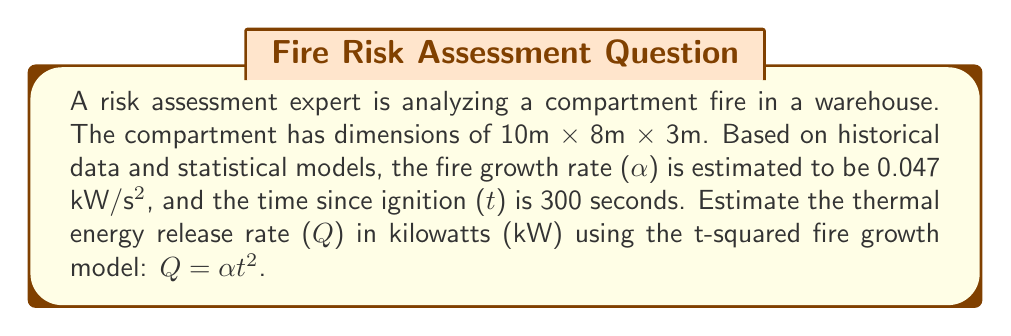Could you help me with this problem? To estimate the thermal energy release rate (Q) in a compartment fire using the t-squared fire growth model, we follow these steps:

1. Identify the given parameters:
   - Fire growth rate (α) = 0.047 kW/s²
   - Time since ignition (t) = 300 seconds

2. Recall the t-squared fire growth model equation:
   $Q = \alpha t^2$

3. Substitute the given values into the equation:
   $Q = 0.047 \text{ kW/s²} \times (300 \text{ s})^2$

4. Calculate the result:
   $Q = 0.047 \times 90,000 = 4,230 \text{ kW}$

The thermal energy release rate is approximately 4,230 kW or 4.23 MW.

Note: This model assumes ideal conditions and doesn't account for factors such as fuel load, ventilation, or compartment effects. In a real-world risk assessment, these factors would need to be considered for a more accurate estimation.
Answer: 4,230 kW 